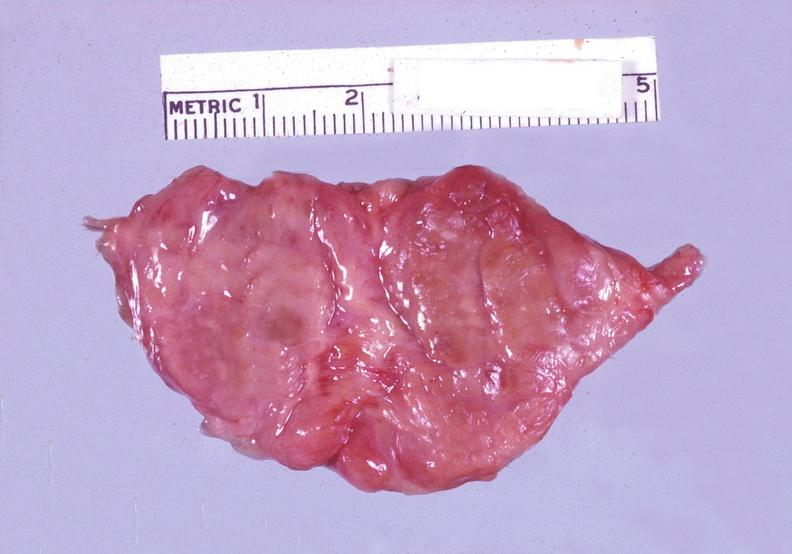does this image show thyroid, hashimotos?
Answer the question using a single word or phrase. Yes 